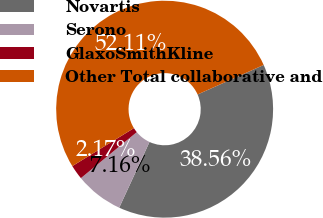<chart> <loc_0><loc_0><loc_500><loc_500><pie_chart><fcel>Novartis<fcel>Serono<fcel>GlaxoSmithKline<fcel>Other Total collaborative and<nl><fcel>38.56%<fcel>7.16%<fcel>2.17%<fcel>52.11%<nl></chart> 